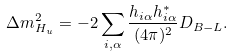Convert formula to latex. <formula><loc_0><loc_0><loc_500><loc_500>\Delta m ^ { 2 } _ { H _ { u } } = - 2 \sum _ { i , \alpha } \frac { h _ { i \alpha } h _ { i \alpha } ^ { * } } { ( 4 \pi ) ^ { 2 } } D _ { B - L } .</formula> 